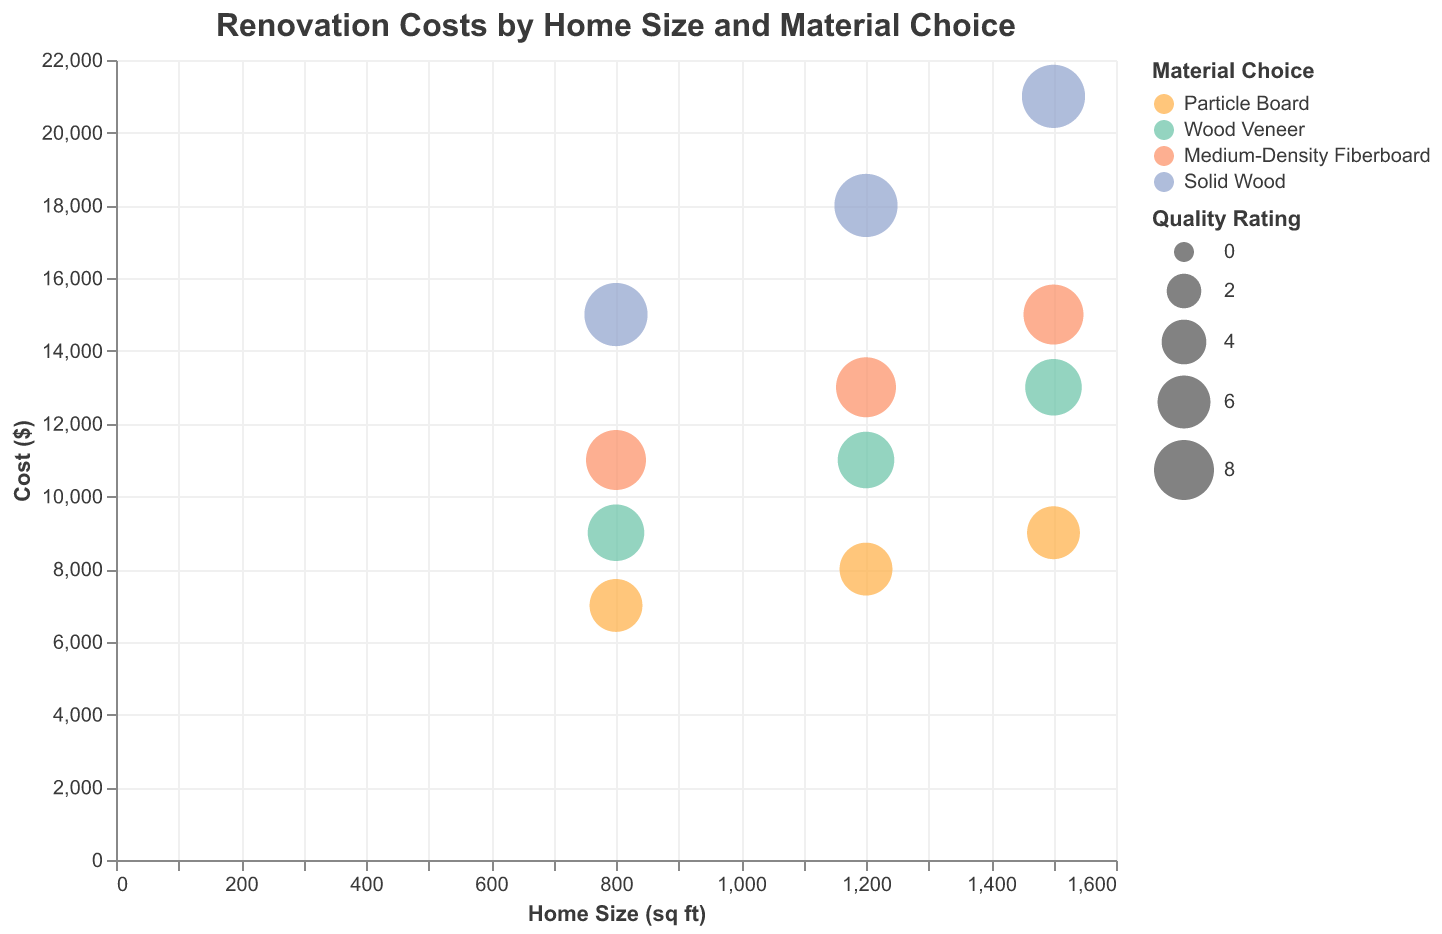What's the title of the chart? The title is usually found at the top of the chart, and it summarizes what the chart is about. In this case, the title is "Renovation Costs by Home Size and Material Choice."
Answer: Renovation Costs by Home Size and Material Choice Which material choice has the highest quality rating? Solid Wood is represented by bubbles with the largest sizes because it has a quality rating of 9, which is the highest on the chart.
Answer: Solid Wood How does the cost change as home size increases for Medium-Density Fiberboard? For Medium-Density Fiberboard, as the home size increases from 800 to 1500 sq ft, the cost also increases from $11,000 to $15,000. This can be seen by following the corresponding color across the home sizes on the x-axis.
Answer: The cost increases What is the difference in cost between Solid Wood and Particle Board for a 1500 sq ft home? For a 1500 sq ft home, Solid Wood costs $21,000, and Particle Board costs $9,000. The difference is calculated as $21,000 - $9,000 = $12,000.
Answer: $12,000 Which material provides the highest quality rating at the lowest cost for an 800 sq ft home? Solid Wood provides the highest quality rating at 9 for an 800 sq ft home but costs $15,000. Particle Board has a lower rating of 6 but costs $7,000. Since "highest quality rating at the lowest cost" is the priority, Particle Board would have the lowest cost, but not the highest rating. The best balance would be Medium-Density Fiberboard, with a rating of 8 and cost of $11,000.
Answer: Medium-Density Fiberboard Among the materials, which one shows the most significant increase in cost as the home size increases from 1200 to 1500 sq ft? As we observe the change in costs from 1200 to 1500 sq ft for each material: Particle Board increases by $1,000, Wood Veneer by $2,000, Medium-Density Fiberboard by $2,000, and Solid Wood by $3,000. Solid Wood shows the most significant increase in cost.
Answer: Solid Wood Compare the cost of Wood Veneer and Medium-Density Fiberboard for a 1200 sq ft home. Which is more expensive and by how much? For a 1200 sq ft home, Wood Veneer costs $11,000, and Medium-Density Fiberboard costs $13,000. The cost difference is $13,000 - $11,000 = $2,000. Medium-Density Fiberboard is more expensive by $2,000.
Answer: Medium-Density Fiberboard, $2,000 What's the average cost of renovation for a Single-Family House across all material choices? The renovation costs for Single-Family Houses are $9,000 for Particle Board, $13,000 for Wood Veneer, $15,000 for Medium-Density Fiberboard, and $21,000 for Solid Wood. The average cost is calculated as (9,000 + 13,000 + 15,000 + 21,000) / 4 = $14,500.
Answer: $14,500 Which material has the closest quality rating to the average quality rating of all materials? The average quality rating of all materials: Particle Board (6), Wood Veneer (7), Medium-Density Fiberboard (8), and Solid Wood (9). The average is (6+7+8+9)/4=7.5. Medium-Density Fiberboard, with a rating of 8, is closest to this average.
Answer: Medium-Density Fiberboard 